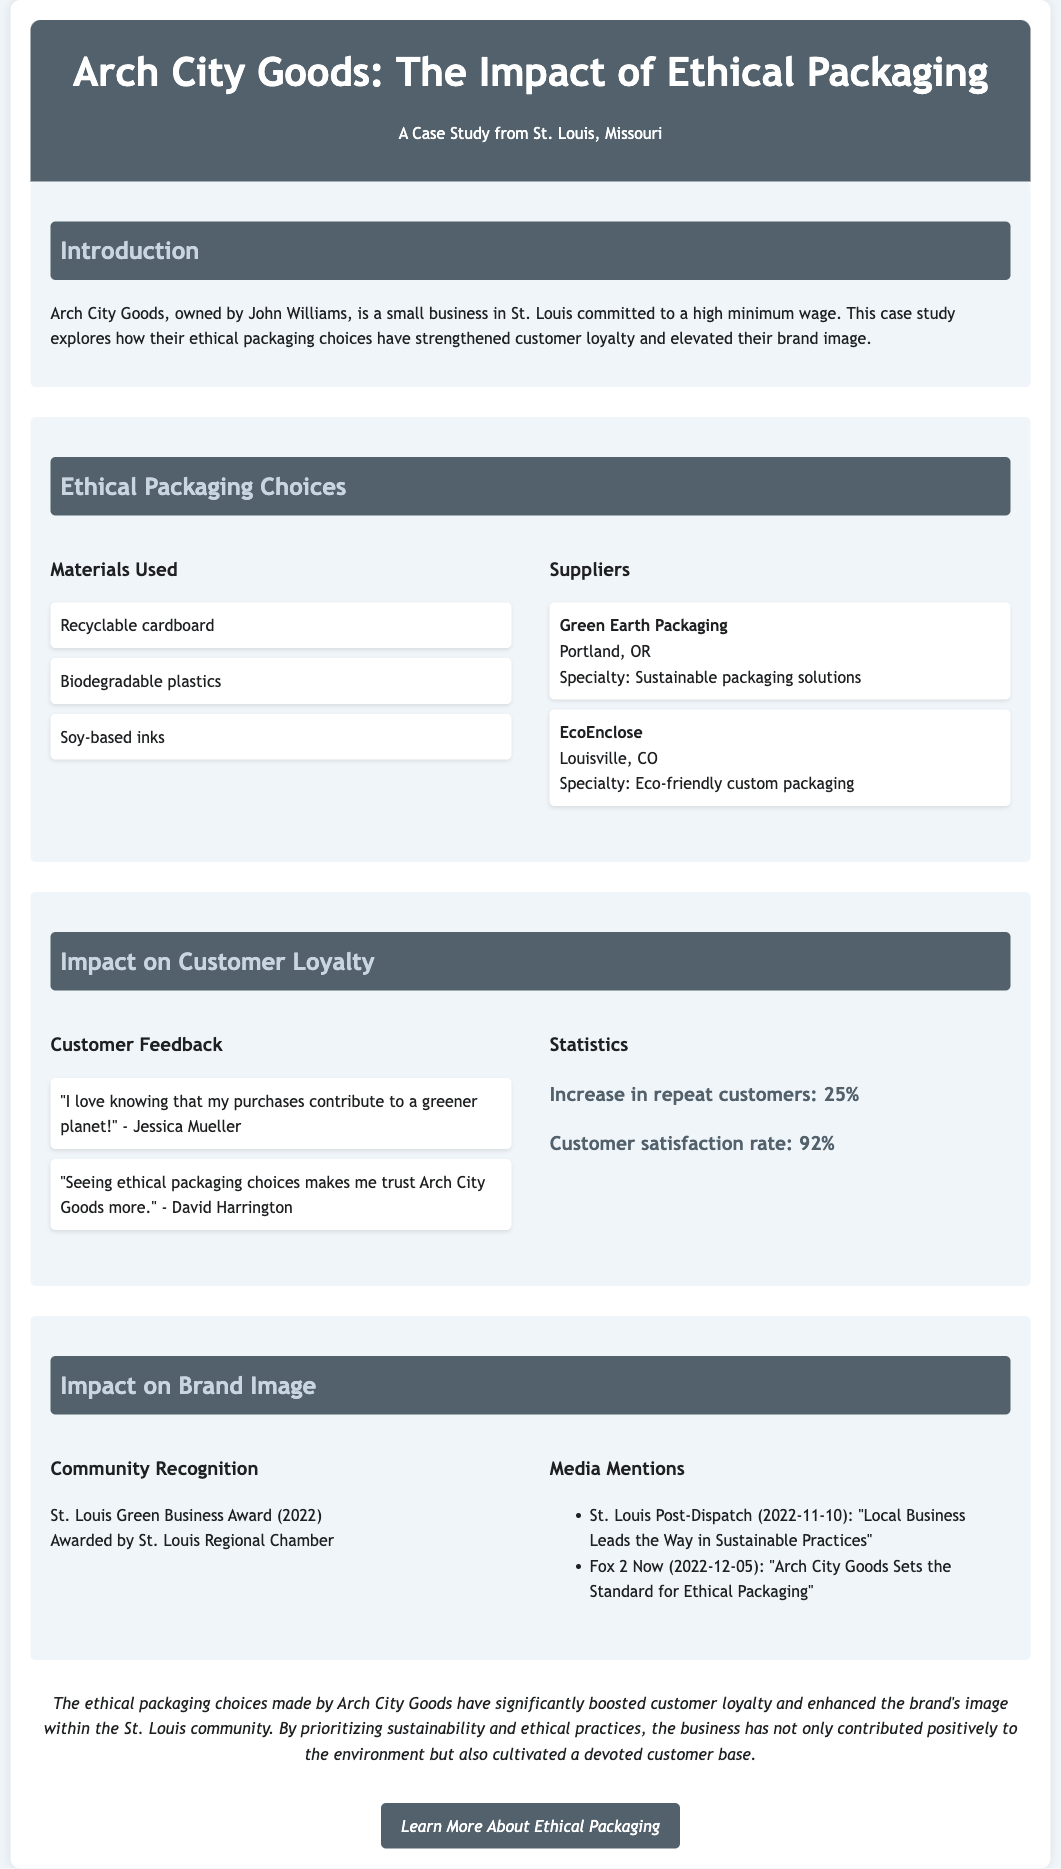what are the materials used for packaging? The materials listed under ethical packaging choices include recyclable cardboard, biodegradable plastics, and soy-based inks.
Answer: recyclable cardboard, biodegradable plastics, soy-based inks who is the owner of Arch City Goods? The document states that John Williams is the owner of Arch City Goods.
Answer: John Williams what percentage increase in repeat customers was reported? The statistics section indicates an increase of 25% in repeat customers.
Answer: 25% which award did Arch City Goods receive in 2022? The document mentions that the business received the St. Louis Green Business Award in 2022.
Answer: St. Louis Green Business Award what is the customer satisfaction rate mentioned in the document? According to the statistics provided, the customer satisfaction rate is 92%.
Answer: 92% why do customers trust Arch City Goods more? Customer feedback indicates that ethical packaging choices make them trust the brand more.
Answer: ethical packaging choices which media outlet featured Arch City Goods in November 2022? The document states that the St. Louis Post-Dispatch mentioned Arch City Goods on November 10, 2022.
Answer: St. Louis Post-Dispatch what two suppliers are mentioned for ethical packaging? The document lists Green Earth Packaging and EcoEnclose as the suppliers.
Answer: Green Earth Packaging, EcoEnclose 